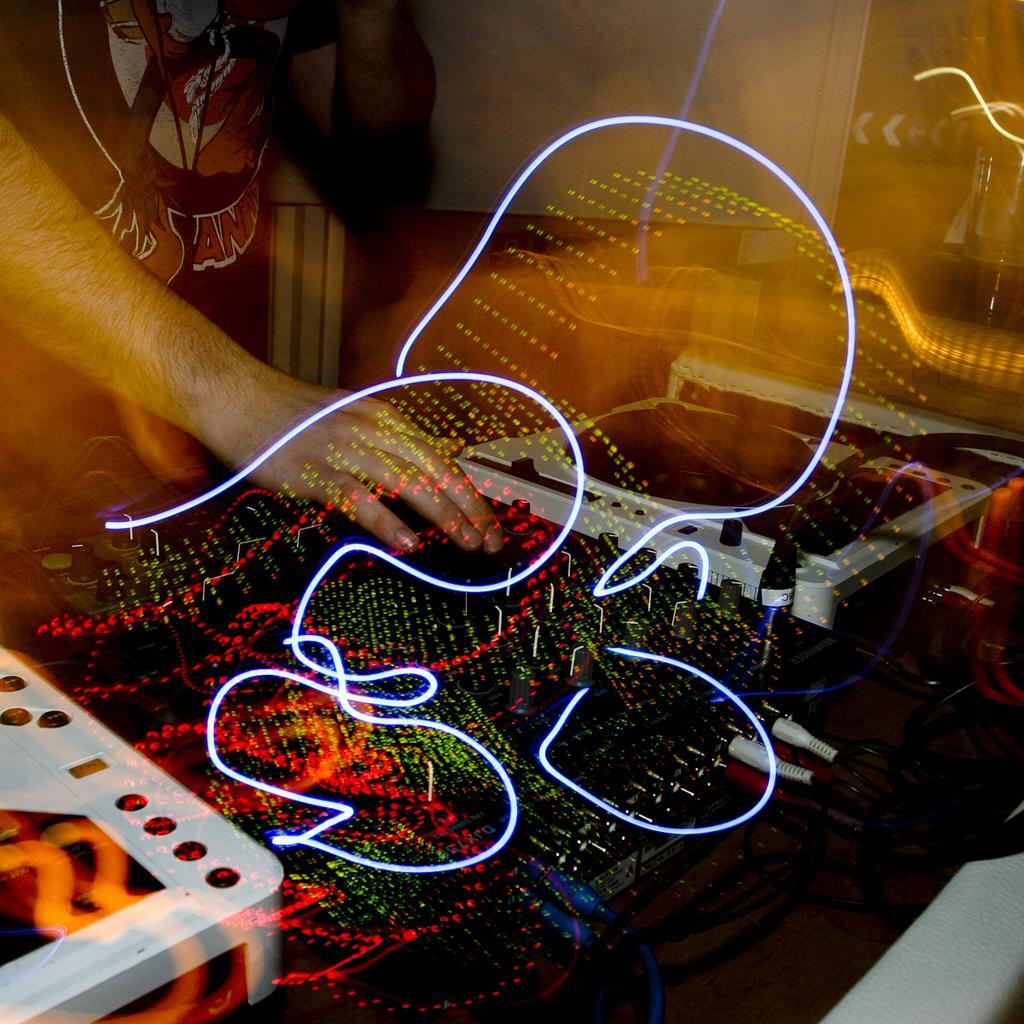Please provide a concise description of this image. In this image DJ is playing the music. In front of him there is a table and on top of it there are some objects. 